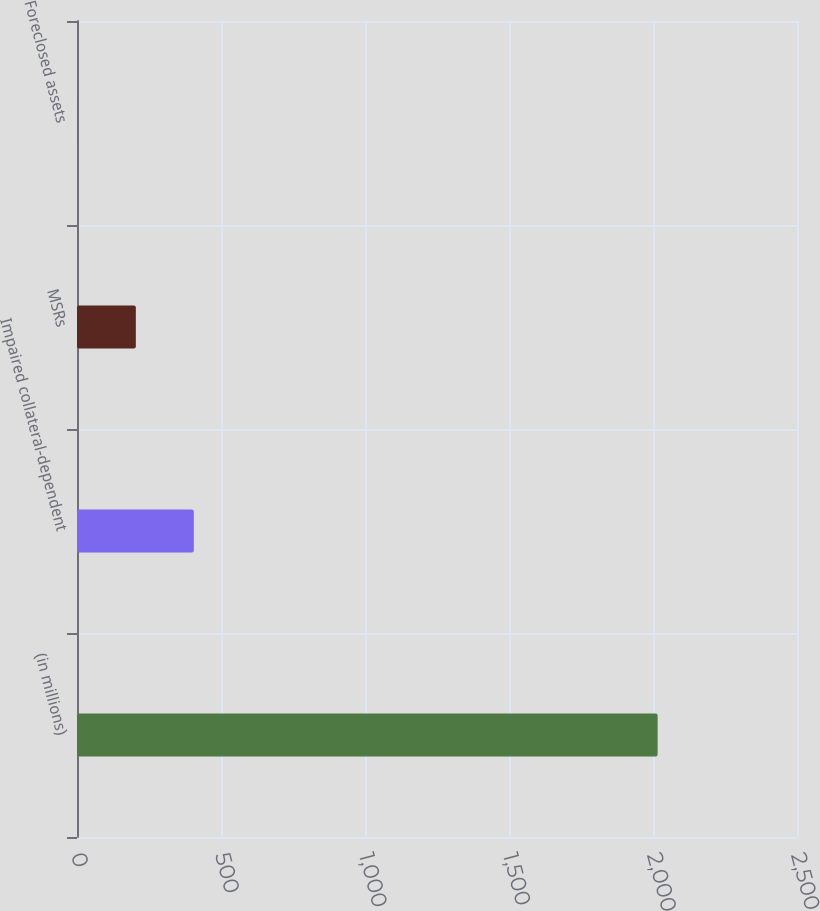<chart> <loc_0><loc_0><loc_500><loc_500><bar_chart><fcel>(in millions)<fcel>Impaired collateral-dependent<fcel>MSRs<fcel>Foreclosed assets<nl><fcel>2016<fcel>405.6<fcel>204.3<fcel>3<nl></chart> 